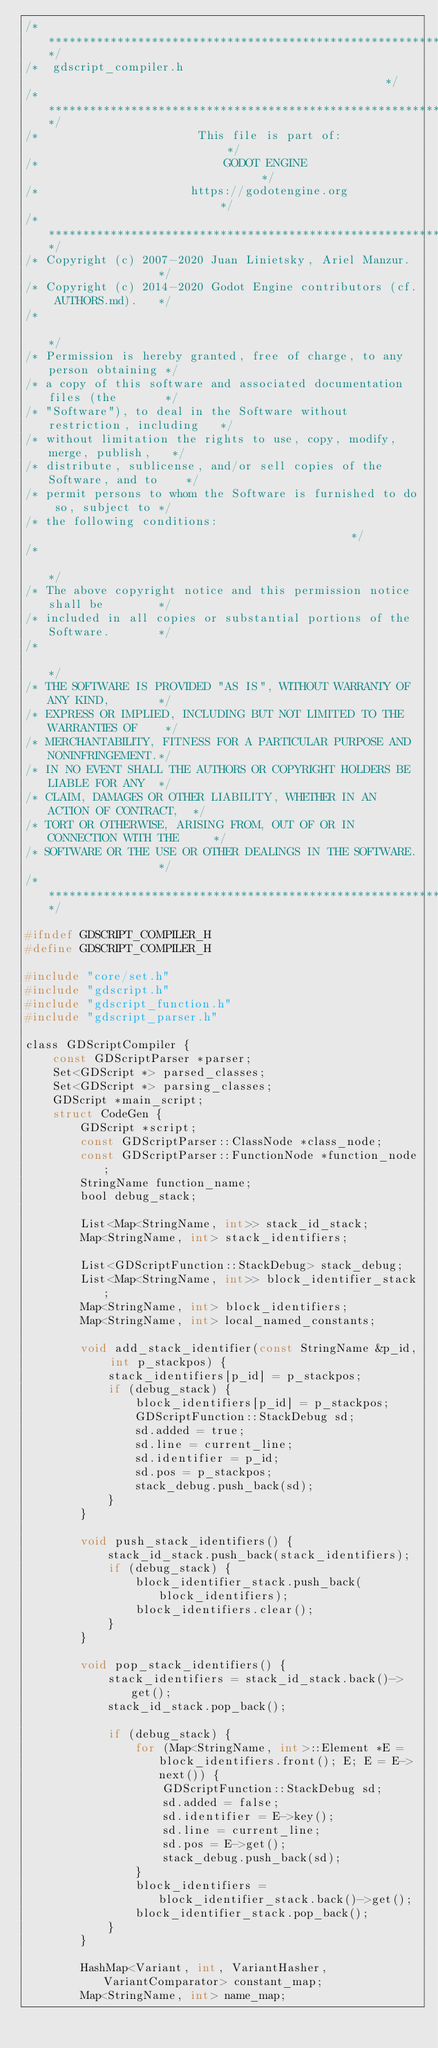Convert code to text. <code><loc_0><loc_0><loc_500><loc_500><_C_>/*************************************************************************/
/*  gdscript_compiler.h                                                  */
/*************************************************************************/
/*                       This file is part of:                           */
/*                           GODOT ENGINE                                */
/*                      https://godotengine.org                          */
/*************************************************************************/
/* Copyright (c) 2007-2020 Juan Linietsky, Ariel Manzur.                 */
/* Copyright (c) 2014-2020 Godot Engine contributors (cf. AUTHORS.md).   */
/*                                                                       */
/* Permission is hereby granted, free of charge, to any person obtaining */
/* a copy of this software and associated documentation files (the       */
/* "Software"), to deal in the Software without restriction, including   */
/* without limitation the rights to use, copy, modify, merge, publish,   */
/* distribute, sublicense, and/or sell copies of the Software, and to    */
/* permit persons to whom the Software is furnished to do so, subject to */
/* the following conditions:                                             */
/*                                                                       */
/* The above copyright notice and this permission notice shall be        */
/* included in all copies or substantial portions of the Software.       */
/*                                                                       */
/* THE SOFTWARE IS PROVIDED "AS IS", WITHOUT WARRANTY OF ANY KIND,       */
/* EXPRESS OR IMPLIED, INCLUDING BUT NOT LIMITED TO THE WARRANTIES OF    */
/* MERCHANTABILITY, FITNESS FOR A PARTICULAR PURPOSE AND NONINFRINGEMENT.*/
/* IN NO EVENT SHALL THE AUTHORS OR COPYRIGHT HOLDERS BE LIABLE FOR ANY  */
/* CLAIM, DAMAGES OR OTHER LIABILITY, WHETHER IN AN ACTION OF CONTRACT,  */
/* TORT OR OTHERWISE, ARISING FROM, OUT OF OR IN CONNECTION WITH THE     */
/* SOFTWARE OR THE USE OR OTHER DEALINGS IN THE SOFTWARE.                */
/*************************************************************************/

#ifndef GDSCRIPT_COMPILER_H
#define GDSCRIPT_COMPILER_H

#include "core/set.h"
#include "gdscript.h"
#include "gdscript_function.h"
#include "gdscript_parser.h"

class GDScriptCompiler {
	const GDScriptParser *parser;
	Set<GDScript *> parsed_classes;
	Set<GDScript *> parsing_classes;
	GDScript *main_script;
	struct CodeGen {
		GDScript *script;
		const GDScriptParser::ClassNode *class_node;
		const GDScriptParser::FunctionNode *function_node;
		StringName function_name;
		bool debug_stack;

		List<Map<StringName, int>> stack_id_stack;
		Map<StringName, int> stack_identifiers;

		List<GDScriptFunction::StackDebug> stack_debug;
		List<Map<StringName, int>> block_identifier_stack;
		Map<StringName, int> block_identifiers;
		Map<StringName, int> local_named_constants;

		void add_stack_identifier(const StringName &p_id, int p_stackpos) {
			stack_identifiers[p_id] = p_stackpos;
			if (debug_stack) {
				block_identifiers[p_id] = p_stackpos;
				GDScriptFunction::StackDebug sd;
				sd.added = true;
				sd.line = current_line;
				sd.identifier = p_id;
				sd.pos = p_stackpos;
				stack_debug.push_back(sd);
			}
		}

		void push_stack_identifiers() {
			stack_id_stack.push_back(stack_identifiers);
			if (debug_stack) {
				block_identifier_stack.push_back(block_identifiers);
				block_identifiers.clear();
			}
		}

		void pop_stack_identifiers() {
			stack_identifiers = stack_id_stack.back()->get();
			stack_id_stack.pop_back();

			if (debug_stack) {
				for (Map<StringName, int>::Element *E = block_identifiers.front(); E; E = E->next()) {
					GDScriptFunction::StackDebug sd;
					sd.added = false;
					sd.identifier = E->key();
					sd.line = current_line;
					sd.pos = E->get();
					stack_debug.push_back(sd);
				}
				block_identifiers = block_identifier_stack.back()->get();
				block_identifier_stack.pop_back();
			}
		}

		HashMap<Variant, int, VariantHasher, VariantComparator> constant_map;
		Map<StringName, int> name_map;</code> 